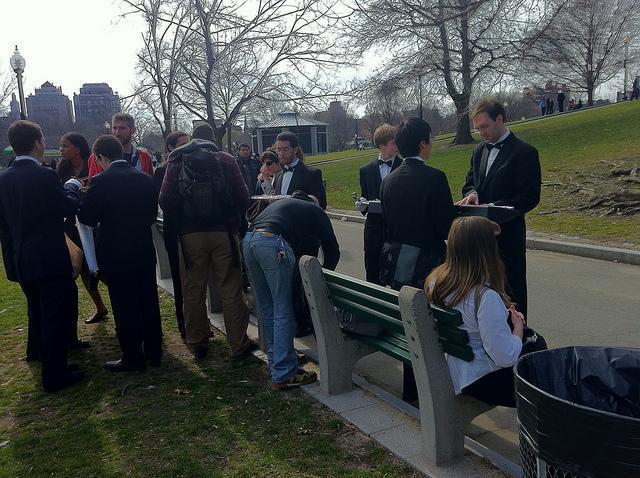How many chairs are visible?
Give a very brief answer. 1. How many people are there?
Give a very brief answer. 9. How many birds are there?
Give a very brief answer. 0. 